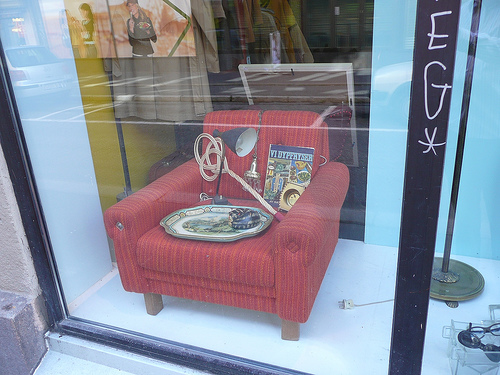<image>
Is there a sofa behind the glass door? Yes. From this viewpoint, the sofa is positioned behind the glass door, with the glass door partially or fully occluding the sofa. 